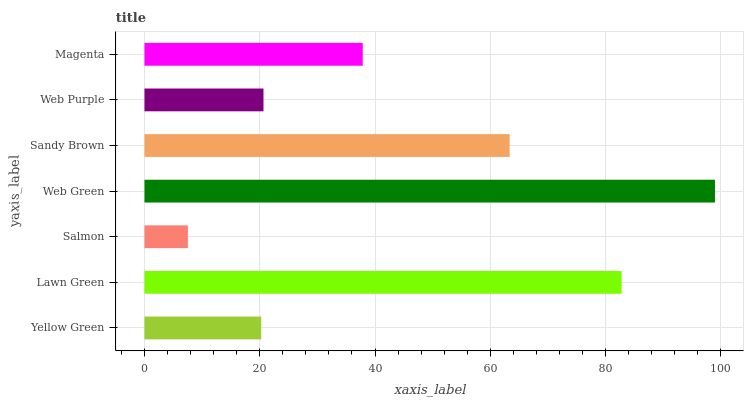Is Salmon the minimum?
Answer yes or no. Yes. Is Web Green the maximum?
Answer yes or no. Yes. Is Lawn Green the minimum?
Answer yes or no. No. Is Lawn Green the maximum?
Answer yes or no. No. Is Lawn Green greater than Yellow Green?
Answer yes or no. Yes. Is Yellow Green less than Lawn Green?
Answer yes or no. Yes. Is Yellow Green greater than Lawn Green?
Answer yes or no. No. Is Lawn Green less than Yellow Green?
Answer yes or no. No. Is Magenta the high median?
Answer yes or no. Yes. Is Magenta the low median?
Answer yes or no. Yes. Is Web Green the high median?
Answer yes or no. No. Is Web Green the low median?
Answer yes or no. No. 